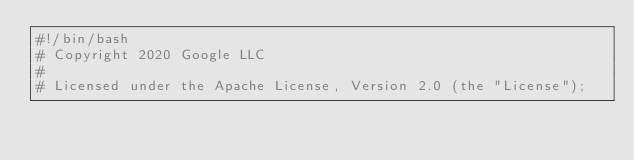<code> <loc_0><loc_0><loc_500><loc_500><_Bash_>#!/bin/bash
# Copyright 2020 Google LLC
#
# Licensed under the Apache License, Version 2.0 (the "License");</code> 